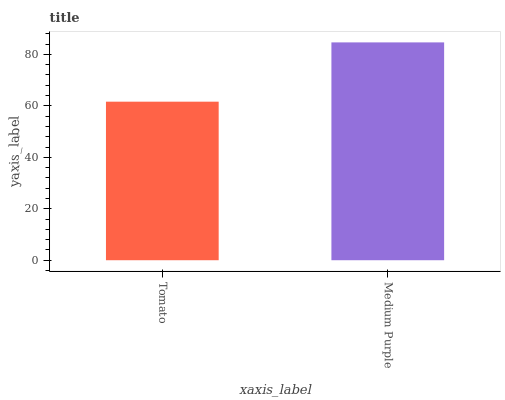Is Tomato the minimum?
Answer yes or no. Yes. Is Medium Purple the maximum?
Answer yes or no. Yes. Is Medium Purple the minimum?
Answer yes or no. No. Is Medium Purple greater than Tomato?
Answer yes or no. Yes. Is Tomato less than Medium Purple?
Answer yes or no. Yes. Is Tomato greater than Medium Purple?
Answer yes or no. No. Is Medium Purple less than Tomato?
Answer yes or no. No. Is Medium Purple the high median?
Answer yes or no. Yes. Is Tomato the low median?
Answer yes or no. Yes. Is Tomato the high median?
Answer yes or no. No. Is Medium Purple the low median?
Answer yes or no. No. 